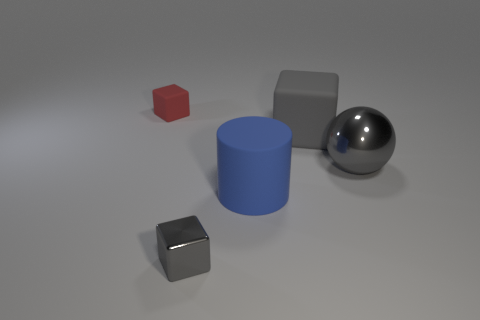Subtract all tiny gray metallic cubes. How many cubes are left? 2 Subtract 1 cubes. How many cubes are left? 2 Add 2 big gray matte cubes. How many objects exist? 7 Subtract all cubes. How many objects are left? 2 Subtract all large blue spheres. Subtract all small matte cubes. How many objects are left? 4 Add 4 large matte cylinders. How many large matte cylinders are left? 5 Add 1 big matte things. How many big matte things exist? 3 Subtract 1 red blocks. How many objects are left? 4 